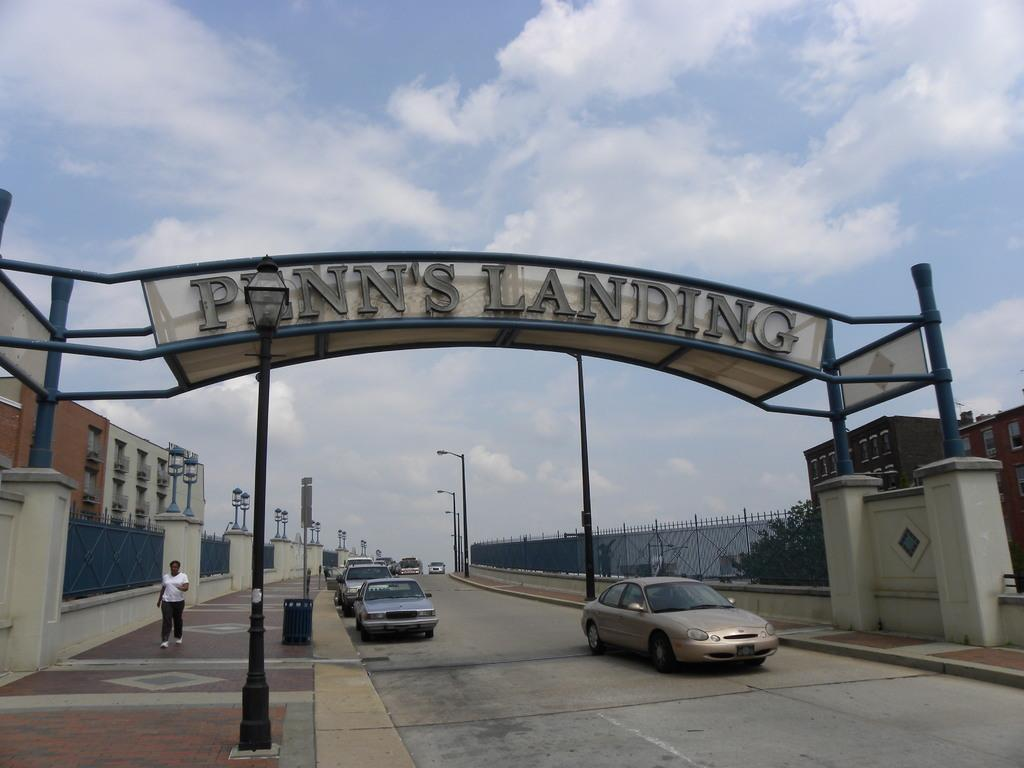What type of structure can be seen in the image? There is an arch in the image. What is happening on the bridge in the image? There are vehicles moving on a bridge in the image. What type of vegetation is on the right side of the image? There are trees on the right side of the image. What type of building is on the left side of the image? There is a building on the left side of the image. What is the condition of the sky in the image? The sky is clear in the image. What type of sticks can be seen in the image? There are no sticks present in the image. What feeling is expressed by the building in the image? Buildings do not express feelings; they are inanimate objects. 